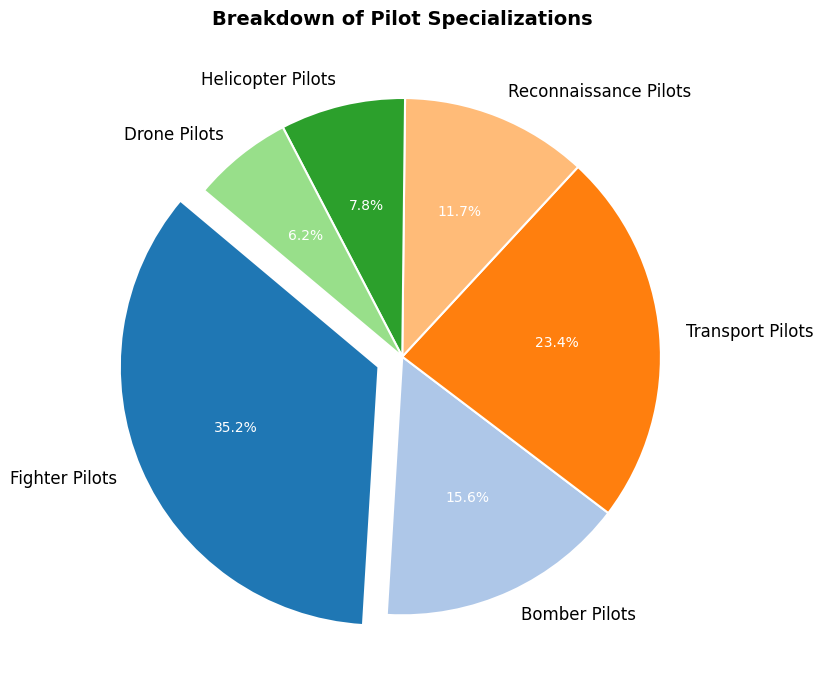Which specialization has the highest number of pilots? Look at the slices of the pie chart and identify which one is the largest. Fighter Pilots have the largest slice, indicating they have the highest number of pilots.
Answer: Fighter Pilots Which specialization has the smallest proportion of pilots? The smallest slice on the pie chart represents the Drone Pilots, indicating they have the smallest proportion.
Answer: Drone Pilots Compare the number of Fighter Pilots to Bomber Pilots. Which group is larger, and by how much? Compare the sizes of the slices for Fighter Pilots and Bomber Pilots. Fighter Pilots' slice is larger. Since Fighter Pilots have 450 and Bomber Pilots have 200, the difference is 450 - 200 = 250.
Answer: Fighter Pilots, by 250 What is the total number of Bomber Pilots, Transport Pilots, and Helicopter Pilots combined? Add the numbers from these specializations. Bomber Pilots: 200, Transport Pilots: 300, Helicopter Pilots: 100. Total = 200 + 300 + 100 = 600.
Answer: 600 Which specialization has nearly half the number of Fighter Pilots? Look for a specialization whose number is approximately half of 450 (225). Bomber Pilots have 200, which is closest to half of 450.
Answer: Bomber Pilots Are there more Drone Pilots than Reconnaissance Pilots? Compare the slices for Drone Pilots and Reconnaissance Pilots. Drone Pilots have 80, and Reconnaissance Pilots have 150. Therefore, there are fewer Drone Pilots.
Answer: No What percentage of pilots are Reconnaissance Pilots? Find the slice labeled Reconnaissance Pilots and read the percentage. The pie chart shows 150 pilots out of a total of 1280, which is approximately 11.7%.
Answer: 11.7% How many more Transport Pilots are there compared to Helicopter Pilots? Compare the numbers of Transport Pilots (300) and Helicopter Pilots (100). The difference is 300 - 100 = 200.
Answer: 200 What is the combined percentage of Drone Pilots and Reconnaissance Pilots? Add the percentages shown on the chart for Drone Pilots (6.3%) and Reconnaissance Pilots (11.7%). 6.3% + 11.7% = 18%.
Answer: 18% Which specialization makes up exactly one-third of the total number of pilots? Calculate one-third of the total pilots (1280). One-third is approximately 427 pilots. The number closest to this is Fighter Pilots with 450, falling nearest to one-third
Answer: Fighter Pilots 